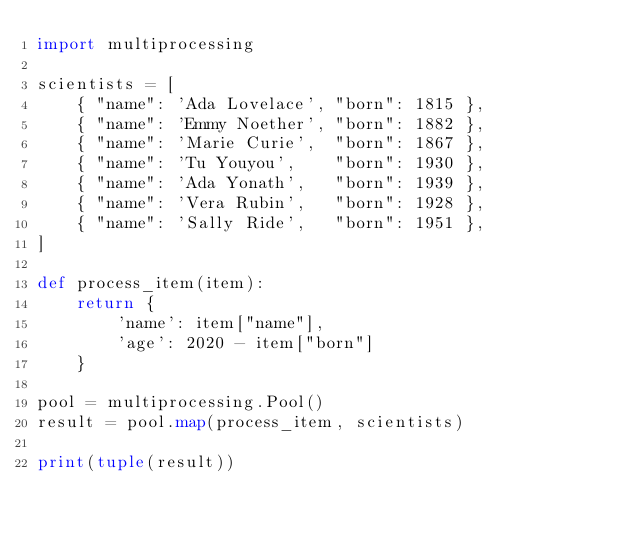<code> <loc_0><loc_0><loc_500><loc_500><_Python_>import multiprocessing

scientists = [
    { "name": 'Ada Lovelace', "born": 1815 },
    { "name": 'Emmy Noether', "born": 1882 },
    { "name": 'Marie Curie',  "born": 1867 },
    { "name": 'Tu Youyou',    "born": 1930 },
    { "name": 'Ada Yonath',   "born": 1939 },
    { "name": 'Vera Rubin',   "born": 1928 },
    { "name": 'Sally Ride',   "born": 1951 },
]

def process_item(item):
    return {
        'name': item["name"],
        'age': 2020 - item["born"]
    }

pool = multiprocessing.Pool()
result = pool.map(process_item, scientists)

print(tuple(result))
</code> 